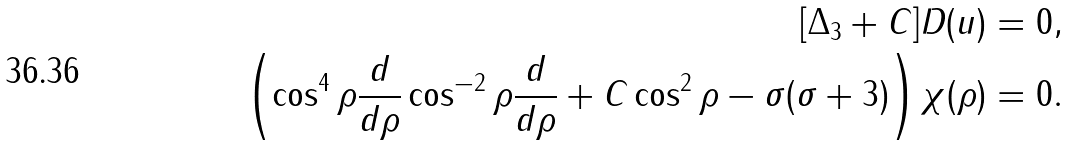<formula> <loc_0><loc_0><loc_500><loc_500>[ \Delta _ { 3 } + C ] D ( u ) = 0 , \\ \left ( \cos ^ { 4 } \rho \frac { d } { d \rho } \cos ^ { - 2 } \rho \frac { d } { d \rho } + C \cos ^ { 2 } \rho - \sigma ( \sigma + 3 ) \right ) \chi ( \rho ) = 0 .</formula> 